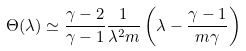Convert formula to latex. <formula><loc_0><loc_0><loc_500><loc_500>\Theta ( \lambda ) \simeq \frac { \gamma - 2 } { \gamma - 1 } \frac { 1 } { \lambda ^ { 2 } m } \left ( \lambda - \frac { \gamma - 1 } { m \gamma } \right )</formula> 